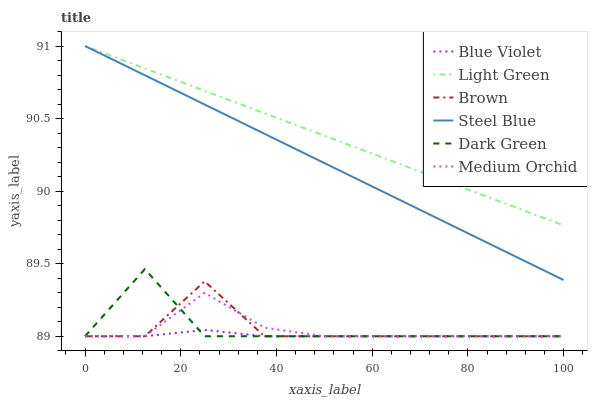Does Blue Violet have the minimum area under the curve?
Answer yes or no. Yes. Does Light Green have the maximum area under the curve?
Answer yes or no. Yes. Does Medium Orchid have the minimum area under the curve?
Answer yes or no. No. Does Medium Orchid have the maximum area under the curve?
Answer yes or no. No. Is Light Green the smoothest?
Answer yes or no. Yes. Is Brown the roughest?
Answer yes or no. Yes. Is Medium Orchid the smoothest?
Answer yes or no. No. Is Medium Orchid the roughest?
Answer yes or no. No. Does Brown have the lowest value?
Answer yes or no. Yes. Does Steel Blue have the lowest value?
Answer yes or no. No. Does Light Green have the highest value?
Answer yes or no. Yes. Does Medium Orchid have the highest value?
Answer yes or no. No. Is Medium Orchid less than Steel Blue?
Answer yes or no. Yes. Is Steel Blue greater than Blue Violet?
Answer yes or no. Yes. Does Medium Orchid intersect Dark Green?
Answer yes or no. Yes. Is Medium Orchid less than Dark Green?
Answer yes or no. No. Is Medium Orchid greater than Dark Green?
Answer yes or no. No. Does Medium Orchid intersect Steel Blue?
Answer yes or no. No. 